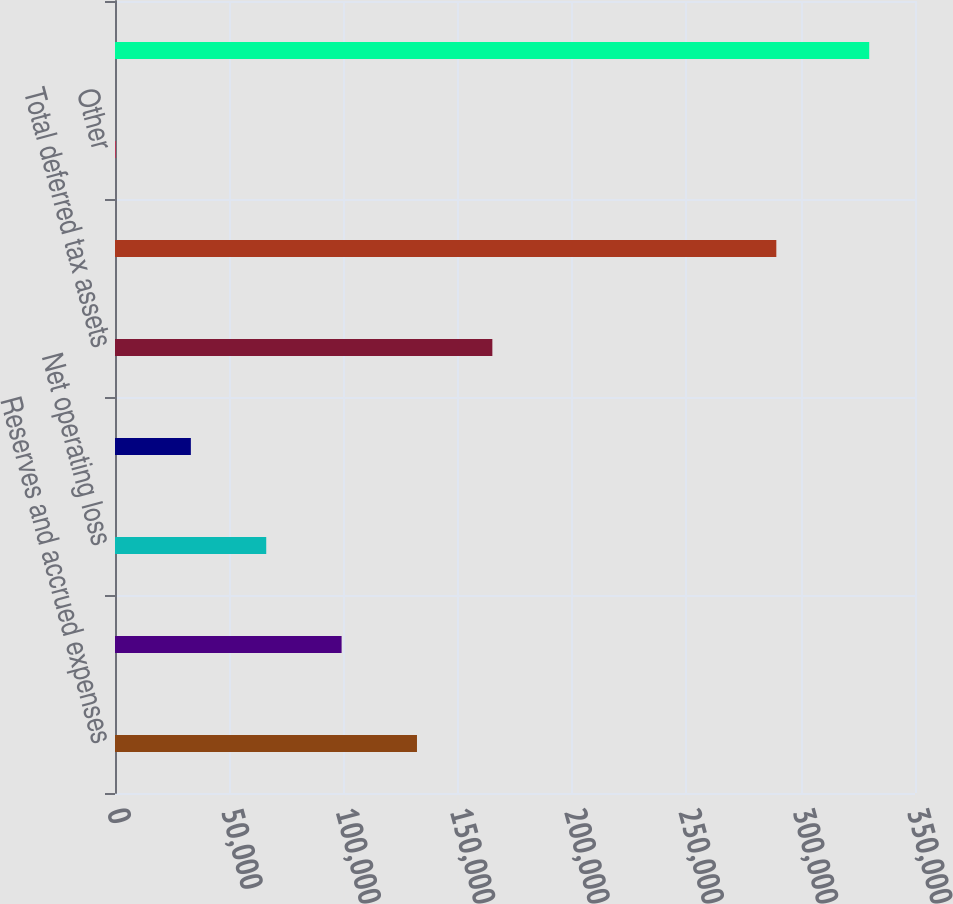Convert chart. <chart><loc_0><loc_0><loc_500><loc_500><bar_chart><fcel>Reserves and accrued expenses<fcel>Inventories<fcel>Net operating loss<fcel>R&D credits<fcel>Total deferred tax assets<fcel>Amortizable intangible assets<fcel>Other<fcel>Total deferred tax liabilities<nl><fcel>132116<fcel>99140.8<fcel>66165.2<fcel>33189.6<fcel>165092<fcel>289326<fcel>214<fcel>329970<nl></chart> 